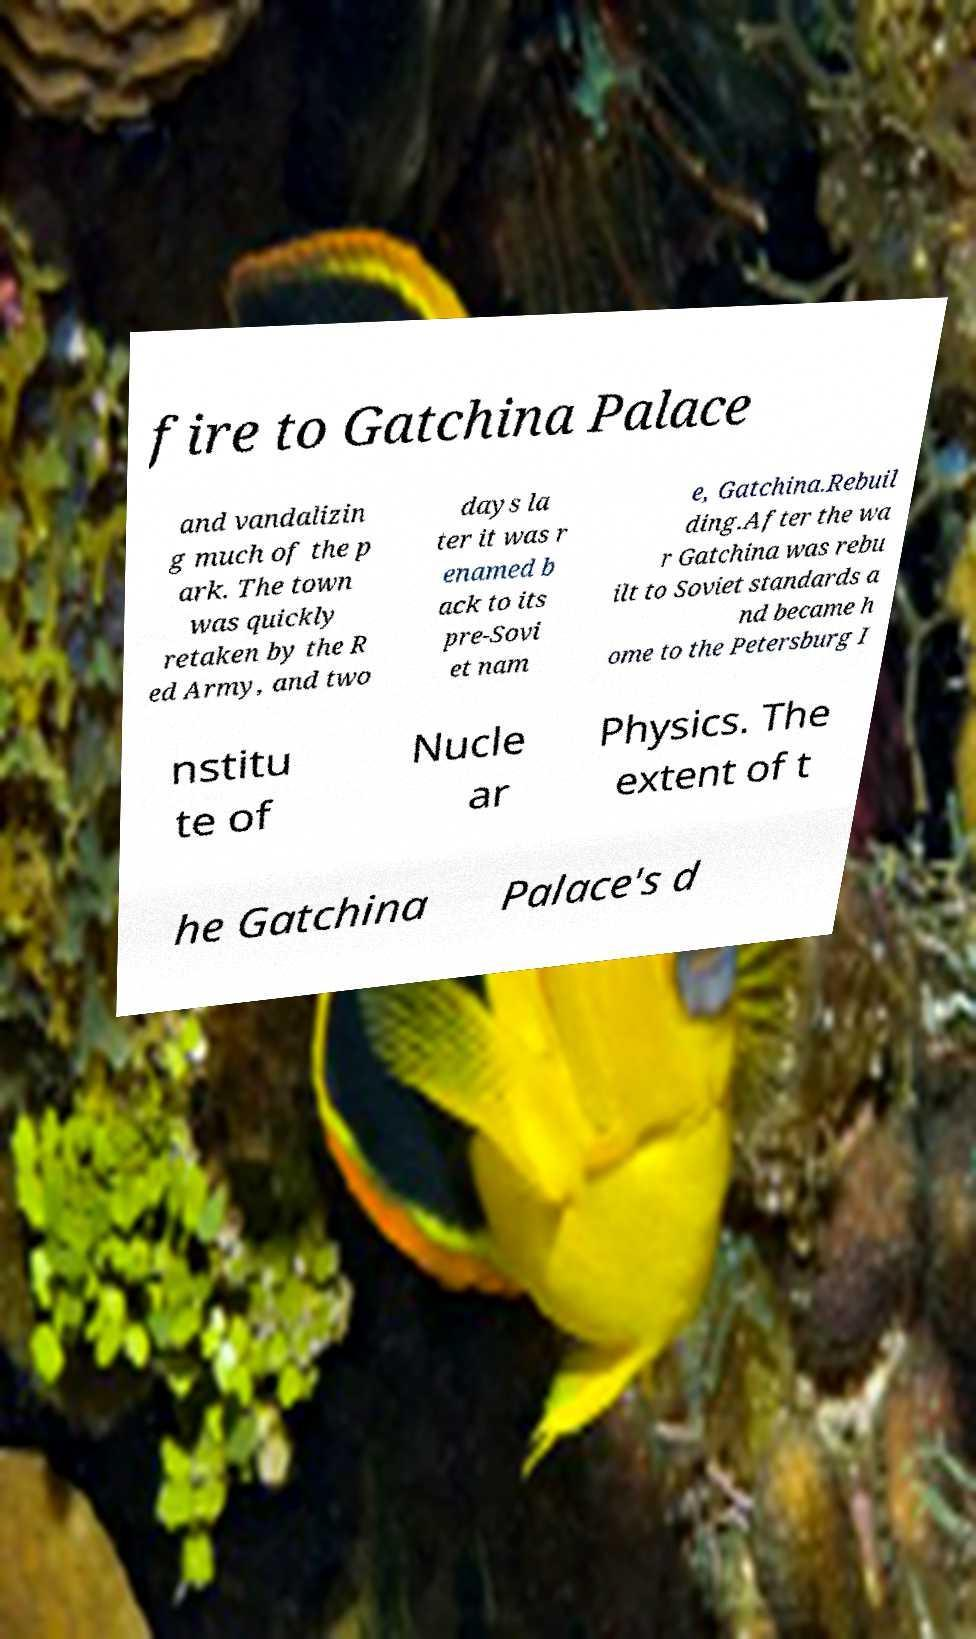There's text embedded in this image that I need extracted. Can you transcribe it verbatim? fire to Gatchina Palace and vandalizin g much of the p ark. The town was quickly retaken by the R ed Army, and two days la ter it was r enamed b ack to its pre-Sovi et nam e, Gatchina.Rebuil ding.After the wa r Gatchina was rebu ilt to Soviet standards a nd became h ome to the Petersburg I nstitu te of Nucle ar Physics. The extent of t he Gatchina Palace's d 